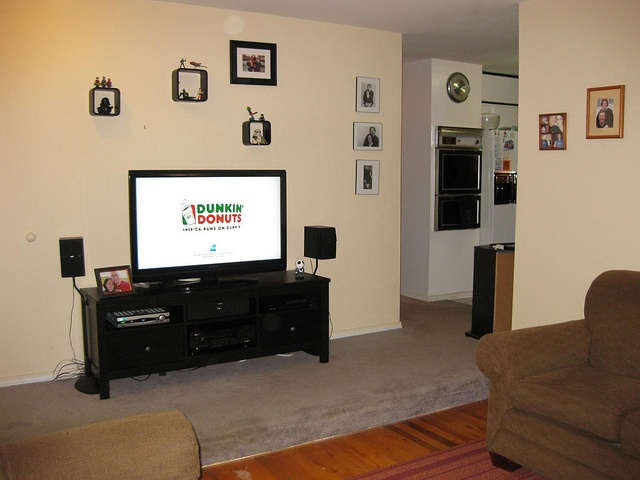Describe the objects in this image and their specific colors. I can see chair in tan, maroon, and black tones, couch in tan, maroon, black, and gray tones, tv in tan, white, black, and darkgray tones, chair in tan, gray, brown, maroon, and olive tones, and couch in tan, gray, brown, and maroon tones in this image. 